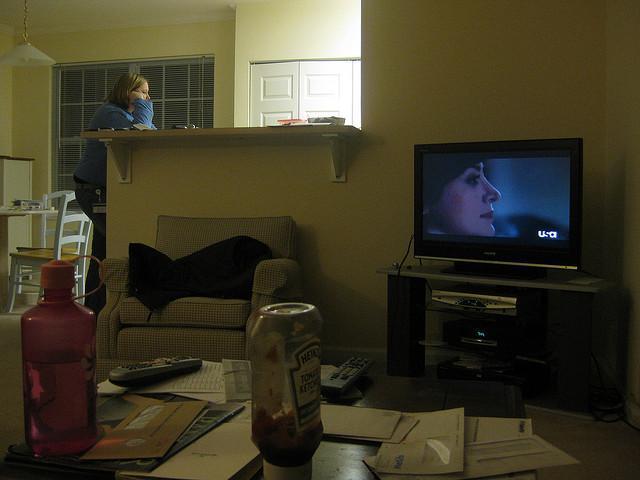How many chairs are visible?
Give a very brief answer. 2. How many people are there?
Give a very brief answer. 2. How many bottles are visible?
Give a very brief answer. 2. 